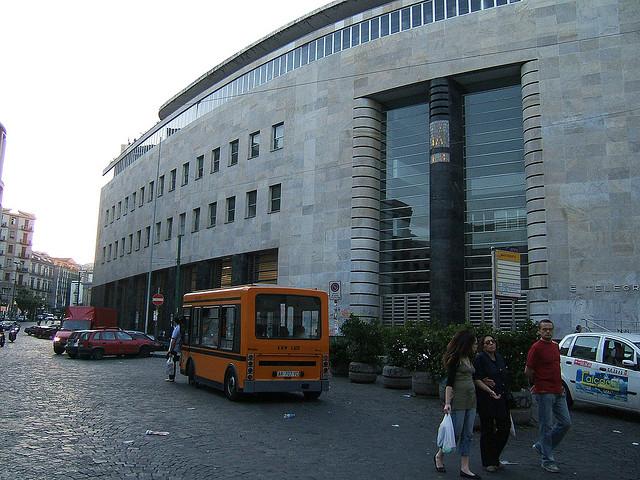What color is the bus?
Be succinct. Orange. How many people are wearing hats?
Quick response, please. 0. Is the building curved?
Keep it brief. Yes. How would you describe the pavement?
Concise answer only. Cobblestone. Is this a streamlined warehouse?
Quick response, please. No. 